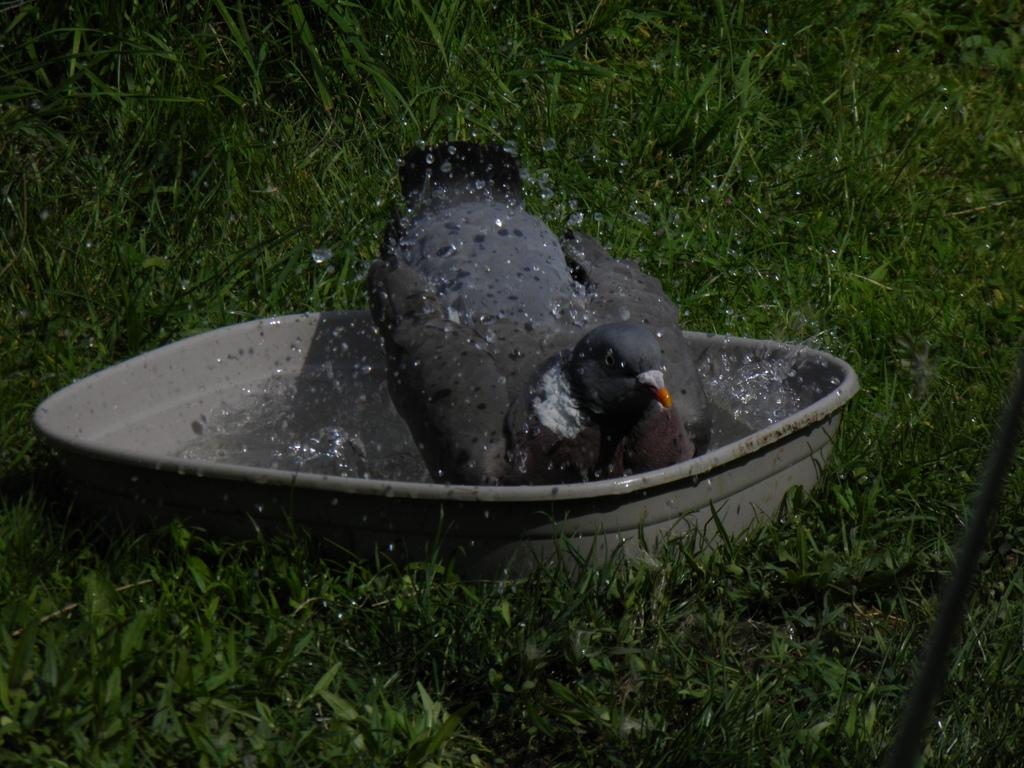What type of animal is in the image? There is a bird in the image. What color is the bird? The bird is black in color. What is the container in the image used for? The container is used to hold water. What type of vegetation is in the image? There is grass in the image. How many flowers does the grandfather plant in the image? There is no grandfather or flowers present in the image. 